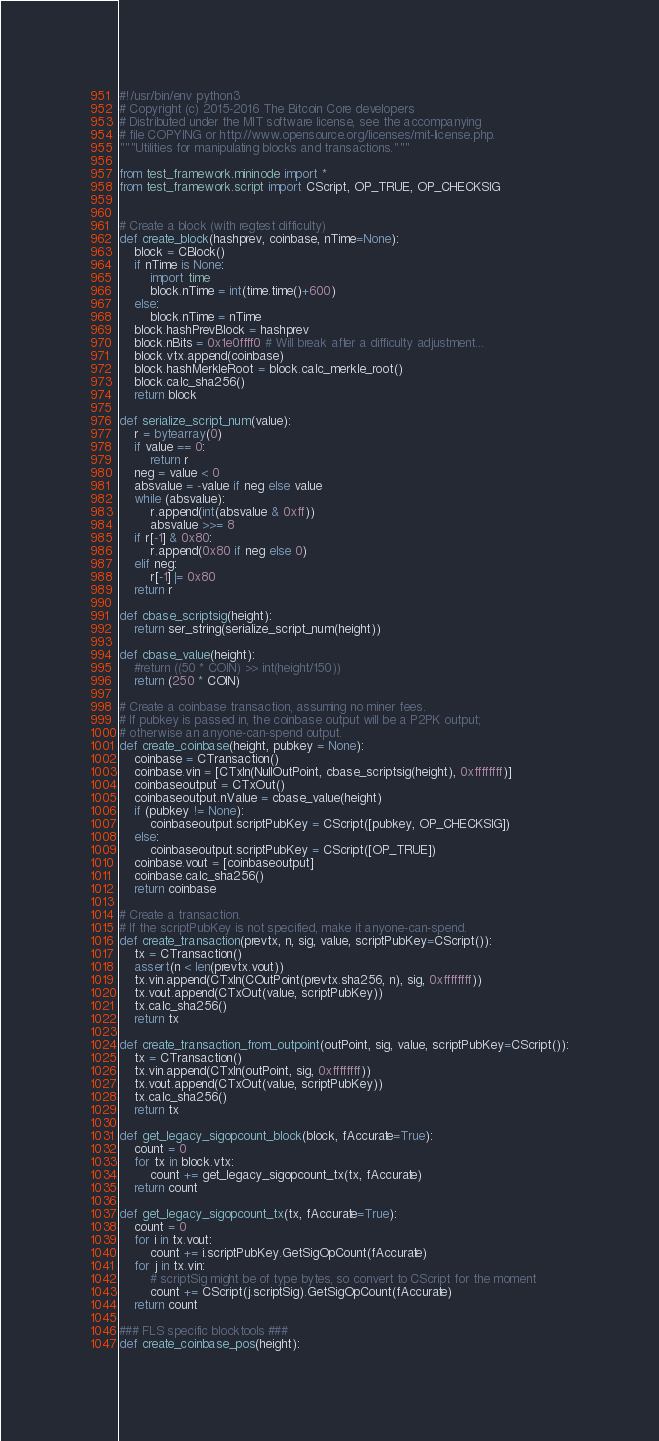Convert code to text. <code><loc_0><loc_0><loc_500><loc_500><_Python_>#!/usr/bin/env python3
# Copyright (c) 2015-2016 The Bitcoin Core developers
# Distributed under the MIT software license, see the accompanying
# file COPYING or http://www.opensource.org/licenses/mit-license.php.
"""Utilities for manipulating blocks and transactions."""

from test_framework.mininode import *
from test_framework.script import CScript, OP_TRUE, OP_CHECKSIG


# Create a block (with regtest difficulty)
def create_block(hashprev, coinbase, nTime=None):
    block = CBlock()
    if nTime is None:
        import time
        block.nTime = int(time.time()+600)
    else:
        block.nTime = nTime
    block.hashPrevBlock = hashprev
    block.nBits = 0x1e0ffff0 # Will break after a difficulty adjustment...
    block.vtx.append(coinbase)
    block.hashMerkleRoot = block.calc_merkle_root()
    block.calc_sha256()
    return block

def serialize_script_num(value):
    r = bytearray(0)
    if value == 0:
        return r
    neg = value < 0
    absvalue = -value if neg else value
    while (absvalue):
        r.append(int(absvalue & 0xff))
        absvalue >>= 8
    if r[-1] & 0x80:
        r.append(0x80 if neg else 0)
    elif neg:
        r[-1] |= 0x80
    return r

def cbase_scriptsig(height):
    return ser_string(serialize_script_num(height))

def cbase_value(height):
    #return ((50 * COIN) >> int(height/150))
    return (250 * COIN)

# Create a coinbase transaction, assuming no miner fees.
# If pubkey is passed in, the coinbase output will be a P2PK output;
# otherwise an anyone-can-spend output.
def create_coinbase(height, pubkey = None):
    coinbase = CTransaction()
    coinbase.vin = [CTxIn(NullOutPoint, cbase_scriptsig(height), 0xffffffff)]
    coinbaseoutput = CTxOut()
    coinbaseoutput.nValue = cbase_value(height)
    if (pubkey != None):
        coinbaseoutput.scriptPubKey = CScript([pubkey, OP_CHECKSIG])
    else:
        coinbaseoutput.scriptPubKey = CScript([OP_TRUE])
    coinbase.vout = [coinbaseoutput]
    coinbase.calc_sha256()
    return coinbase

# Create a transaction.
# If the scriptPubKey is not specified, make it anyone-can-spend.
def create_transaction(prevtx, n, sig, value, scriptPubKey=CScript()):
    tx = CTransaction()
    assert(n < len(prevtx.vout))
    tx.vin.append(CTxIn(COutPoint(prevtx.sha256, n), sig, 0xffffffff))
    tx.vout.append(CTxOut(value, scriptPubKey))
    tx.calc_sha256()
    return tx

def create_transaction_from_outpoint(outPoint, sig, value, scriptPubKey=CScript()):
    tx = CTransaction()
    tx.vin.append(CTxIn(outPoint, sig, 0xffffffff))
    tx.vout.append(CTxOut(value, scriptPubKey))
    tx.calc_sha256()
    return tx

def get_legacy_sigopcount_block(block, fAccurate=True):
    count = 0
    for tx in block.vtx:
        count += get_legacy_sigopcount_tx(tx, fAccurate)
    return count

def get_legacy_sigopcount_tx(tx, fAccurate=True):
    count = 0
    for i in tx.vout:
        count += i.scriptPubKey.GetSigOpCount(fAccurate)
    for j in tx.vin:
        # scriptSig might be of type bytes, so convert to CScript for the moment
        count += CScript(j.scriptSig).GetSigOpCount(fAccurate)
    return count

### FLS specific blocktools ###
def create_coinbase_pos(height):</code> 